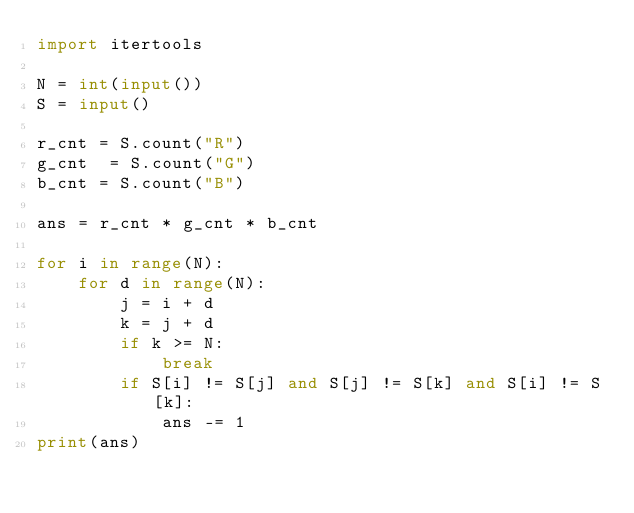Convert code to text. <code><loc_0><loc_0><loc_500><loc_500><_Python_>import itertools

N = int(input())
S = input()

r_cnt = S.count("R")
g_cnt  = S.count("G")
b_cnt = S.count("B")

ans = r_cnt * g_cnt * b_cnt

for i in range(N):
    for d in range(N):
        j = i + d
        k = j + d
        if k >= N:
            break
        if S[i] != S[j] and S[j] != S[k] and S[i] != S[k]:
            ans -= 1
print(ans)</code> 